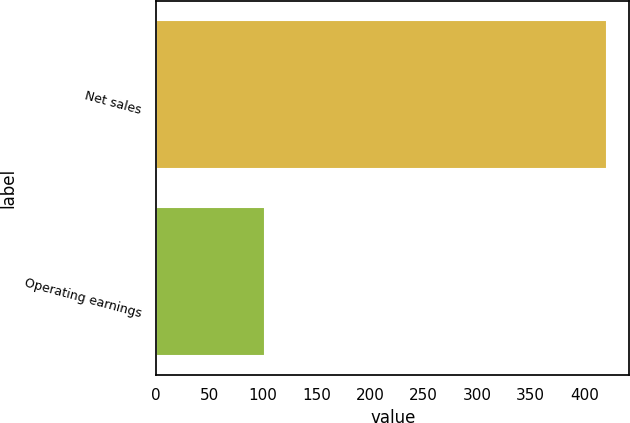Convert chart. <chart><loc_0><loc_0><loc_500><loc_500><bar_chart><fcel>Net sales<fcel>Operating earnings<nl><fcel>421<fcel>102<nl></chart> 